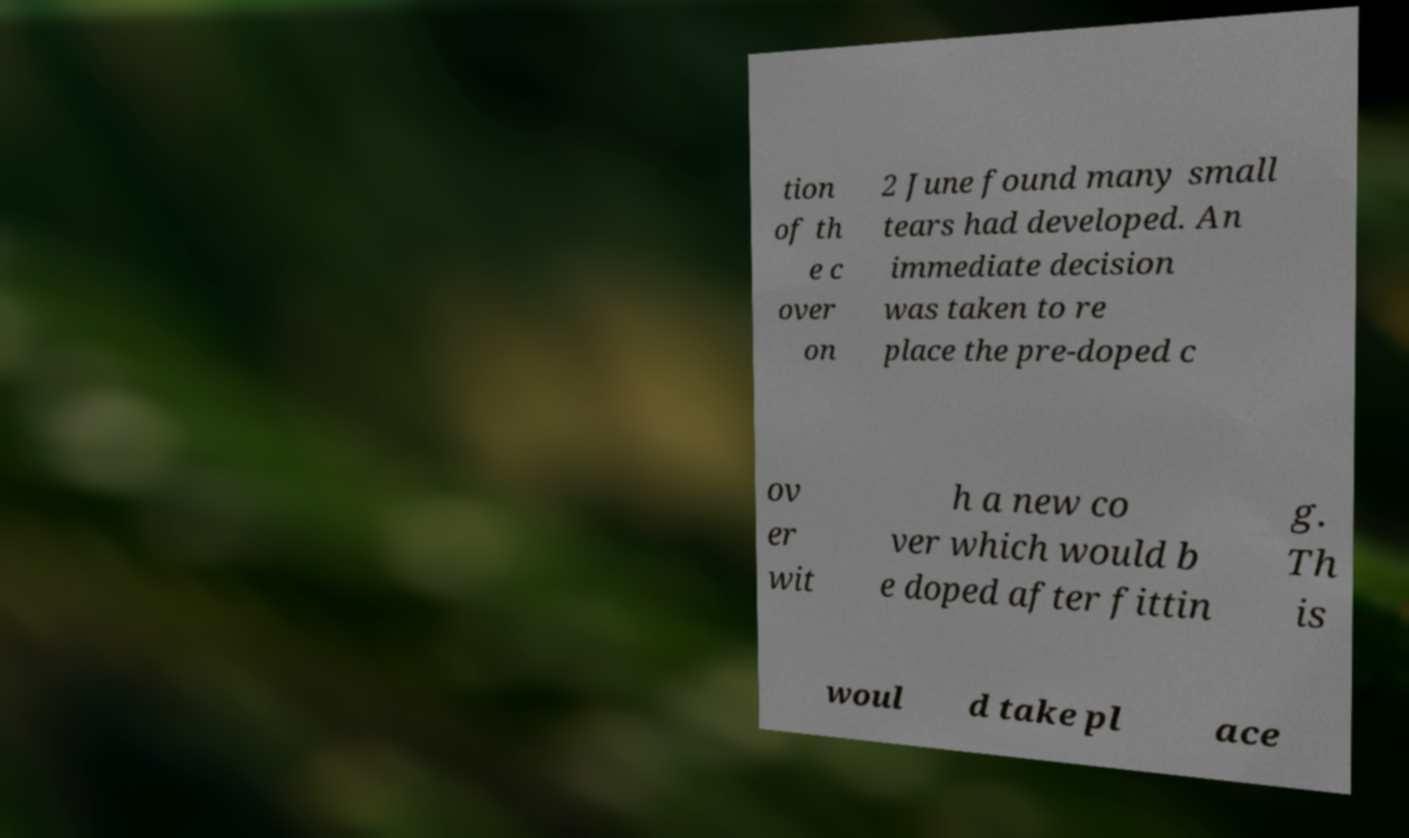I need the written content from this picture converted into text. Can you do that? tion of th e c over on 2 June found many small tears had developed. An immediate decision was taken to re place the pre-doped c ov er wit h a new co ver which would b e doped after fittin g. Th is woul d take pl ace 